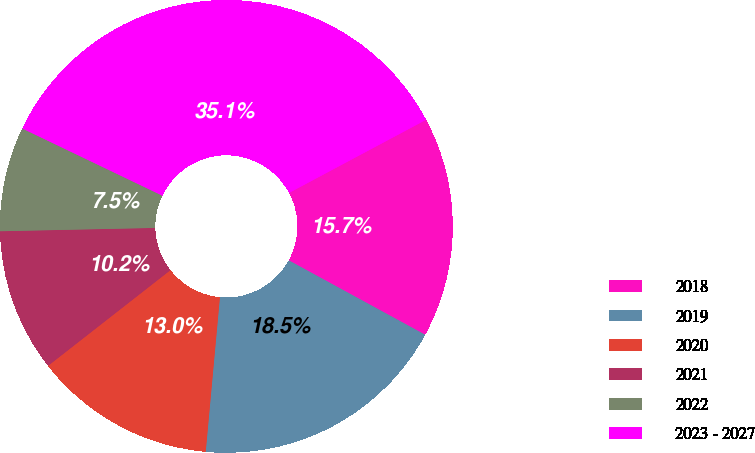Convert chart to OTSL. <chart><loc_0><loc_0><loc_500><loc_500><pie_chart><fcel>2018<fcel>2019<fcel>2020<fcel>2021<fcel>2022<fcel>2023 - 2027<nl><fcel>15.75%<fcel>18.51%<fcel>12.98%<fcel>10.22%<fcel>7.46%<fcel>35.08%<nl></chart> 